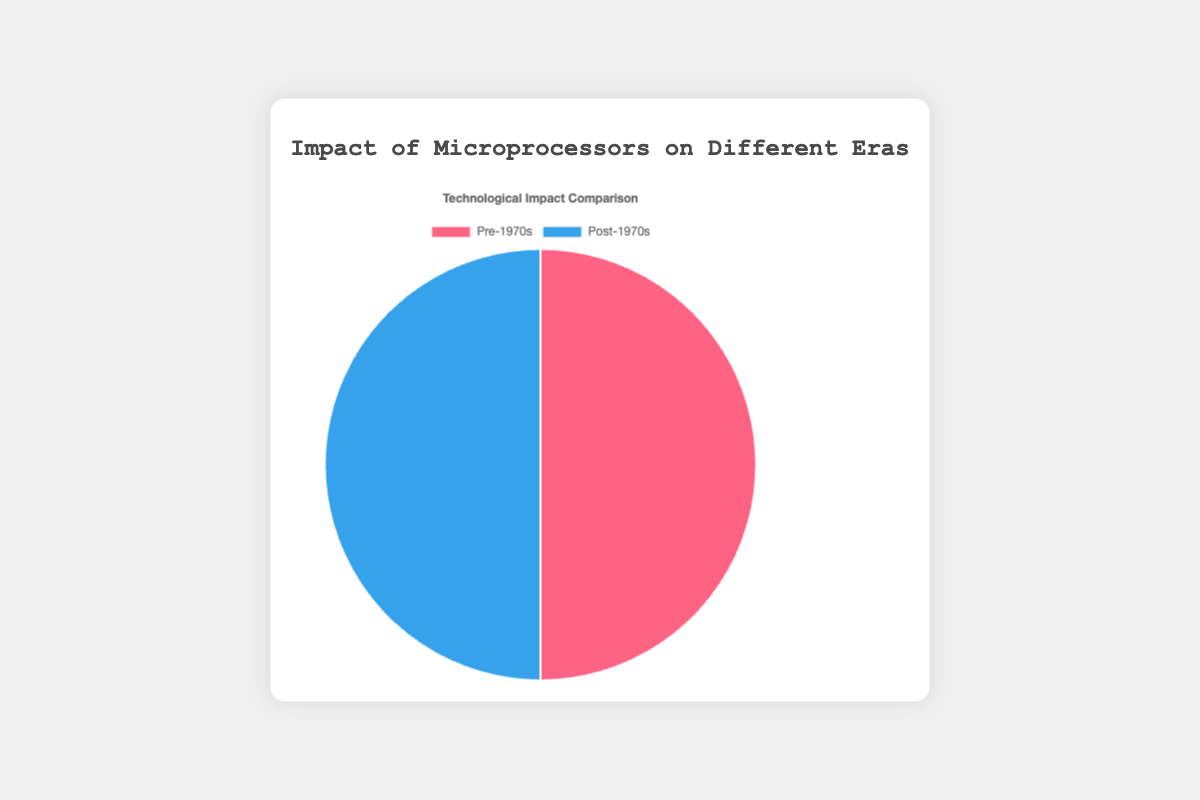What are the two eras compared in the pie chart? The chart compares two different time periods: Pre-1970s and Post-1970s. Each era represents a sum of impacts across various technological advancements.
Answer: Pre-1970s and Post-1970s Which era has a higher impact on Communication technology? The Post-1970s era has a higher impact on Communication technology, as indicated by the larger slice of the pie chart for Communication in that era compared to the Pre-1970s era.
Answer: Post-1970s What is the combined impact of Computing and Entertainment in the Pre-1970s era? The impact of Computing in the Pre-1970s era is 30, and the impact of Entertainment is 20. Adding these together gives a combined impact of 30 + 20 = 50.
Answer: 50 Compare the impact on Automation between the Pre-1970s and Post-1970s eras. Which era has a higher impact, and by how much? The Pre-1970s era has an impact of 15 on Automation, while the Post-1970s era has an impact of 10. The Pre-1970s era has a higher impact by 15 - 10 = 5.
Answer: Pre-1970s, by 5 Calculate the average impact of technological advancements in the Post-1970s era. The impacts in the Post-1970s era are 40 (Communication), 25 (Computing), 10 (Automation), 15 (Entertainment), and 10 (Research). Summing these gives 40 + 25 + 10 + 15 + 10 = 100. The average impact is 100 / 5 = 20.
Answer: 20 What color represents the Post-1970s era in the pie chart? The Post-1970s era slice in the pie chart is colored blue.
Answer: Blue Which category has the least impact in both eras, and what is that impact value? In both the Pre-1970s and Post-1970s eras, the Research category has the least impact, with a value of 10.
Answer: Research, 10 By how much does the impact on Communication in the Post-1970s era exceed the impact on Communication in the Pre-1970s era? The impact on Communication in the Post-1970s era is 40, while in the Pre-1970s era it is 25. The difference is 40 - 25 = 15.
Answer: 15 